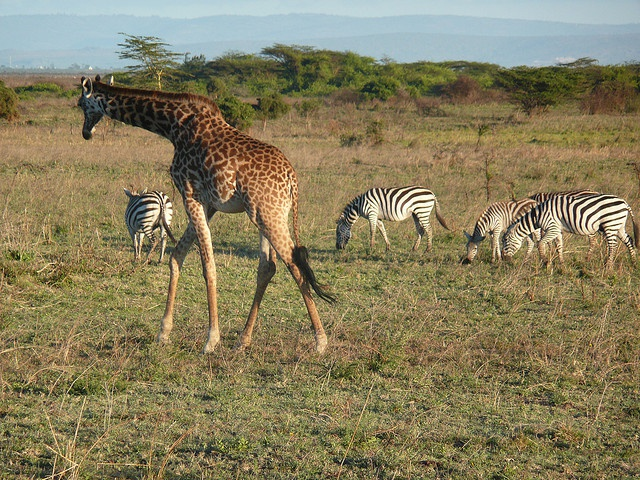Describe the objects in this image and their specific colors. I can see giraffe in lightblue, black, maroon, and gray tones, zebra in lightblue, beige, black, khaki, and gray tones, zebra in lightblue, beige, black, gray, and tan tones, zebra in lightblue, gray, black, beige, and tan tones, and zebra in lightblue, tan, and gray tones in this image. 